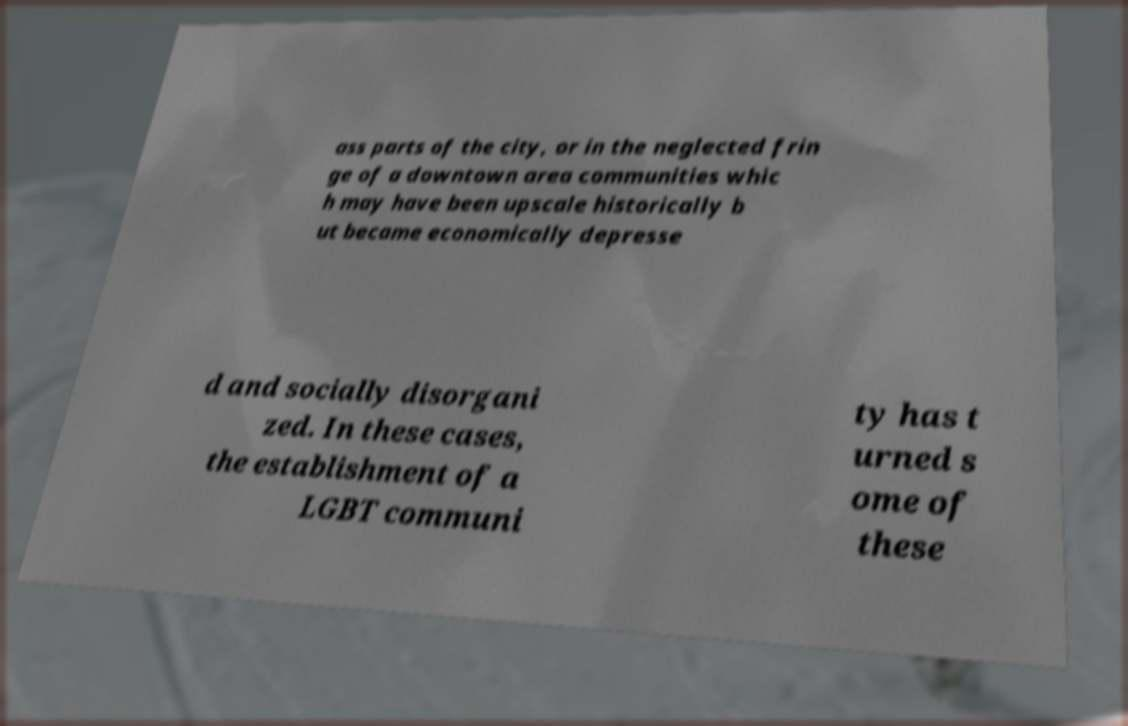Please identify and transcribe the text found in this image. ass parts of the city, or in the neglected frin ge of a downtown area communities whic h may have been upscale historically b ut became economically depresse d and socially disorgani zed. In these cases, the establishment of a LGBT communi ty has t urned s ome of these 